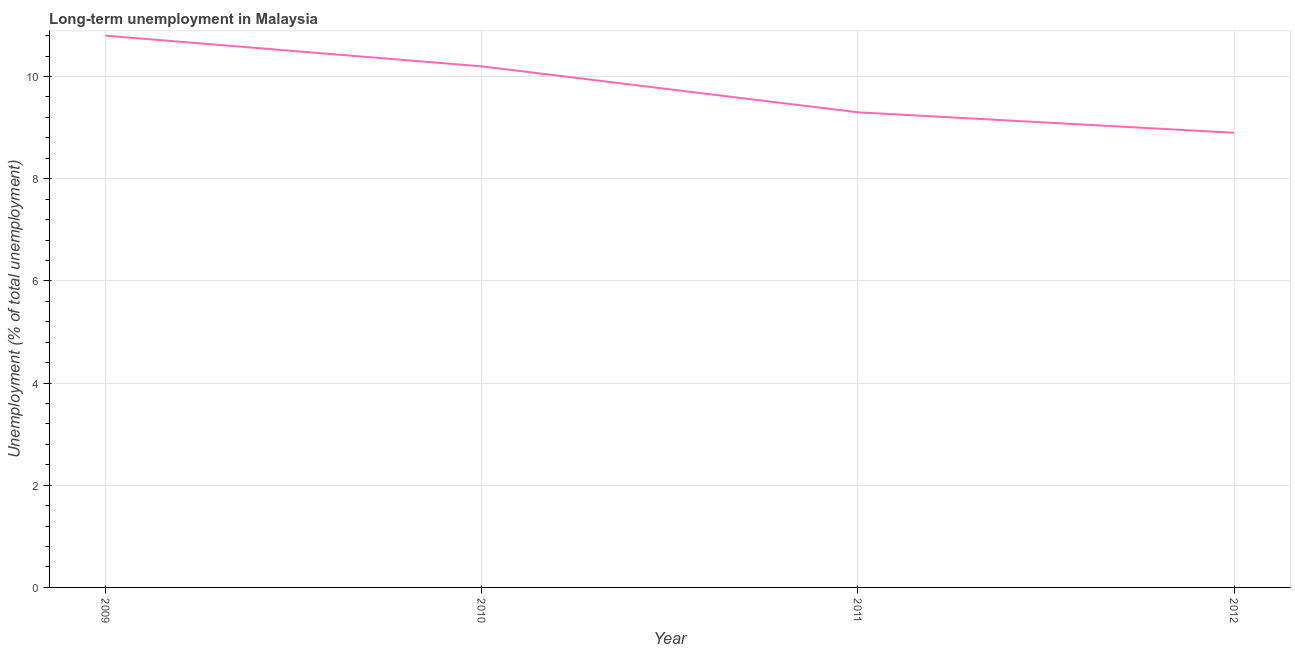What is the long-term unemployment in 2011?
Make the answer very short. 9.3. Across all years, what is the maximum long-term unemployment?
Your answer should be very brief. 10.8. Across all years, what is the minimum long-term unemployment?
Offer a terse response. 8.9. In which year was the long-term unemployment maximum?
Your response must be concise. 2009. In which year was the long-term unemployment minimum?
Provide a succinct answer. 2012. What is the sum of the long-term unemployment?
Provide a short and direct response. 39.2. What is the difference between the long-term unemployment in 2009 and 2010?
Keep it short and to the point. 0.6. What is the average long-term unemployment per year?
Provide a short and direct response. 9.8. What is the median long-term unemployment?
Offer a terse response. 9.75. In how many years, is the long-term unemployment greater than 2 %?
Offer a terse response. 4. What is the ratio of the long-term unemployment in 2009 to that in 2011?
Your answer should be very brief. 1.16. Is the difference between the long-term unemployment in 2009 and 2012 greater than the difference between any two years?
Keep it short and to the point. Yes. What is the difference between the highest and the second highest long-term unemployment?
Your answer should be very brief. 0.6. What is the difference between the highest and the lowest long-term unemployment?
Provide a succinct answer. 1.9. How many lines are there?
Make the answer very short. 1. Does the graph contain grids?
Your answer should be compact. Yes. What is the title of the graph?
Make the answer very short. Long-term unemployment in Malaysia. What is the label or title of the X-axis?
Provide a short and direct response. Year. What is the label or title of the Y-axis?
Provide a short and direct response. Unemployment (% of total unemployment). What is the Unemployment (% of total unemployment) in 2009?
Give a very brief answer. 10.8. What is the Unemployment (% of total unemployment) of 2010?
Offer a terse response. 10.2. What is the Unemployment (% of total unemployment) of 2011?
Keep it short and to the point. 9.3. What is the Unemployment (% of total unemployment) in 2012?
Your answer should be very brief. 8.9. What is the difference between the Unemployment (% of total unemployment) in 2009 and 2011?
Give a very brief answer. 1.5. What is the difference between the Unemployment (% of total unemployment) in 2010 and 2011?
Make the answer very short. 0.9. What is the difference between the Unemployment (% of total unemployment) in 2011 and 2012?
Offer a very short reply. 0.4. What is the ratio of the Unemployment (% of total unemployment) in 2009 to that in 2010?
Provide a short and direct response. 1.06. What is the ratio of the Unemployment (% of total unemployment) in 2009 to that in 2011?
Make the answer very short. 1.16. What is the ratio of the Unemployment (% of total unemployment) in 2009 to that in 2012?
Offer a very short reply. 1.21. What is the ratio of the Unemployment (% of total unemployment) in 2010 to that in 2011?
Make the answer very short. 1.1. What is the ratio of the Unemployment (% of total unemployment) in 2010 to that in 2012?
Offer a very short reply. 1.15. What is the ratio of the Unemployment (% of total unemployment) in 2011 to that in 2012?
Provide a short and direct response. 1.04. 